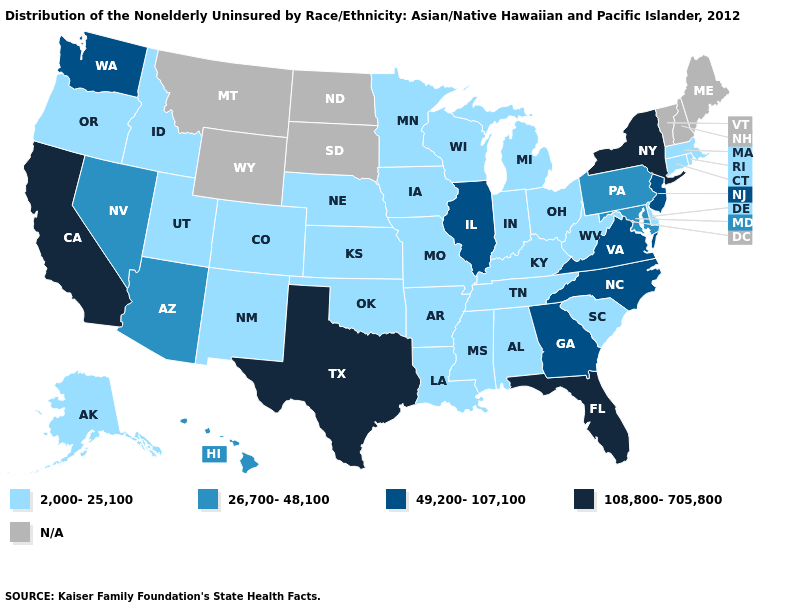Does Florida have the lowest value in the USA?
Concise answer only. No. Does Washington have the lowest value in the USA?
Keep it brief. No. Name the states that have a value in the range N/A?
Quick response, please. Maine, Montana, New Hampshire, North Dakota, South Dakota, Vermont, Wyoming. How many symbols are there in the legend?
Quick response, please. 5. Which states have the lowest value in the USA?
Keep it brief. Alabama, Alaska, Arkansas, Colorado, Connecticut, Delaware, Idaho, Indiana, Iowa, Kansas, Kentucky, Louisiana, Massachusetts, Michigan, Minnesota, Mississippi, Missouri, Nebraska, New Mexico, Ohio, Oklahoma, Oregon, Rhode Island, South Carolina, Tennessee, Utah, West Virginia, Wisconsin. What is the highest value in the USA?
Keep it brief. 108,800-705,800. Among the states that border Idaho , does Utah have the lowest value?
Write a very short answer. Yes. Name the states that have a value in the range 26,700-48,100?
Quick response, please. Arizona, Hawaii, Maryland, Nevada, Pennsylvania. Does the first symbol in the legend represent the smallest category?
Quick response, please. Yes. Which states have the lowest value in the Northeast?
Short answer required. Connecticut, Massachusetts, Rhode Island. Does Delaware have the highest value in the USA?
Answer briefly. No. Name the states that have a value in the range 26,700-48,100?
Answer briefly. Arizona, Hawaii, Maryland, Nevada, Pennsylvania. What is the lowest value in the USA?
Concise answer only. 2,000-25,100. Name the states that have a value in the range 108,800-705,800?
Short answer required. California, Florida, New York, Texas. Which states have the lowest value in the USA?
Answer briefly. Alabama, Alaska, Arkansas, Colorado, Connecticut, Delaware, Idaho, Indiana, Iowa, Kansas, Kentucky, Louisiana, Massachusetts, Michigan, Minnesota, Mississippi, Missouri, Nebraska, New Mexico, Ohio, Oklahoma, Oregon, Rhode Island, South Carolina, Tennessee, Utah, West Virginia, Wisconsin. 